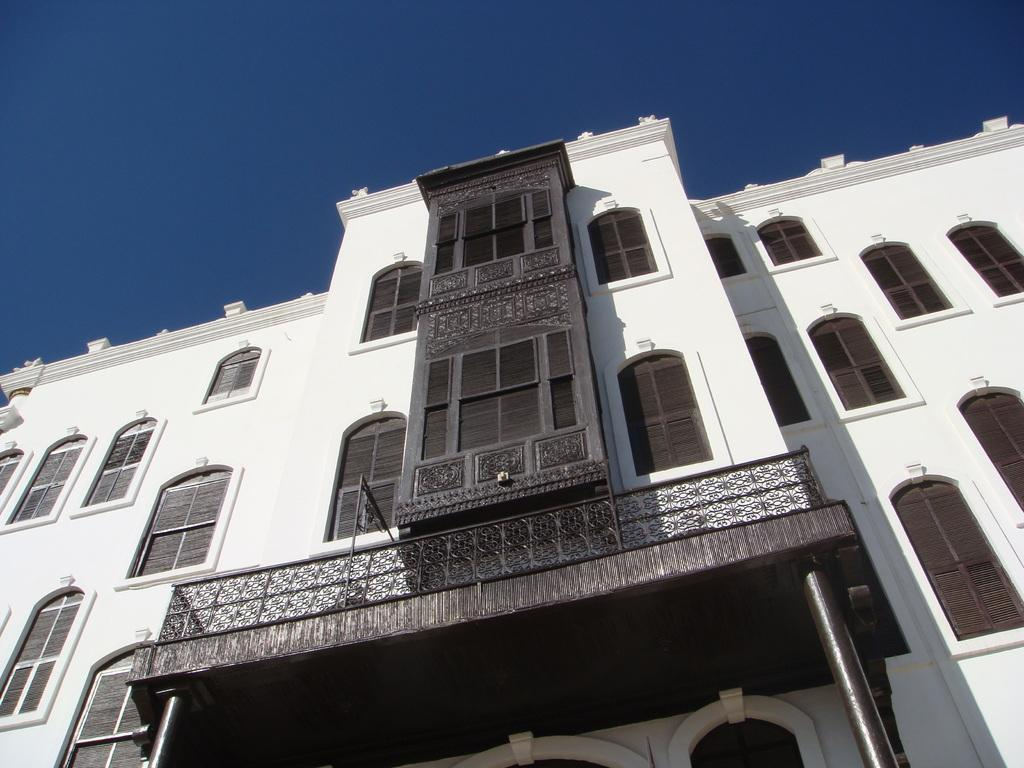What is the color of the building in the image? The building in the image is white. What feature can be observed on the building? The building has many windows. What is the color of the sky in the image? The sky is blue in the image. Can you see any goldfish swimming in the building's windows in the image? There are no goldfish present in the image; it features a white building with many windows. Is there a cup placed on top of the building in the image? There is no cup visible on top of the building in the image. 